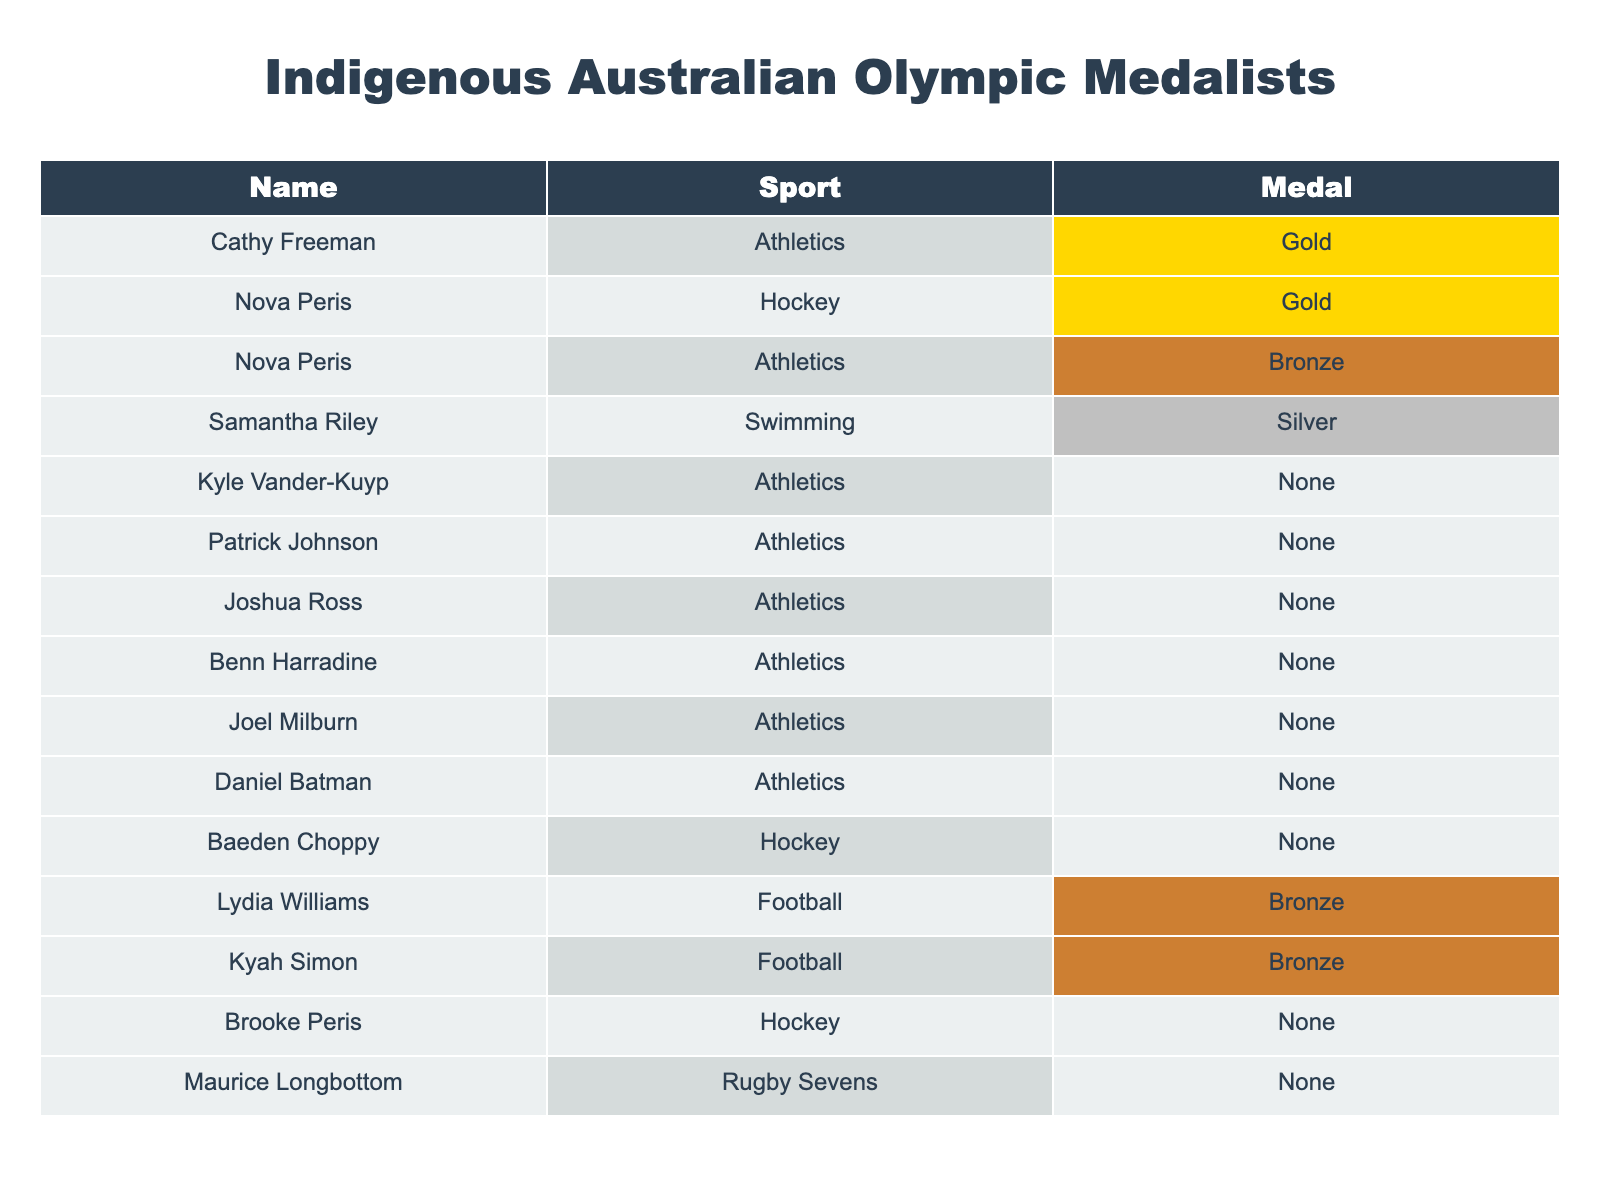What sport did Cathy Freeman compete in? Cathy Freeman's row in the table indicates her sport is Athletics.
Answer: Athletics How many gold medals did Nova Peris win in total? Nova Peris is listed with one gold medal in Hockey and also participated in Athletics where she won a bronze medal. Therefore, her total gold medals are 1.
Answer: 1 Did any Indigenous Australian athlete win a gold medal in Swimming? Looking through the table, the entries show that none of the athletes in the Swimming row have a gold medal. Samantha Riley won silver and bronze but no gold.
Answer: No Which Indigenous athlete earned medals in both Hockey and Athletics? Examining the table, Nova Peris is noted for winning a gold medal in Hockey and also participated in Athletics, where she earned a bronze medal.
Answer: Nova Peris How many athletes won medals in Football? The table lists two athletes, Lydia Williams and Kyah Simon, who each won a bronze medal in Football, indicating that they are the only ones who earned medals in this sport.
Answer: 2 What is the total number of medals won by athletes in Athletics? In the Athletics section, summary of medals shows that while Cathy Freeman has one gold, the others (Kyle Vander-Kuyp, Patrick Johnson, Joshua Ross, Benn Harradine, Joel Milburn, Daniel Batman) did not win medals, thus total medals are 1.
Answer: 1 Is there any athlete in the table who has not won any medals? The table lists Baeden Choppy, Kyle Vander-Kuyp, Patrick Johnson, Joshua Ross, Benn Harradine, Joel Milburn, Daniel Batman, and Maurice Longbottom, all of whom have no medals, confirming that there are multiple athletes without any wins.
Answer: Yes Which athlete has the most medals and how many? The only athlete with a medal count above zero is Cathy Freeman, who has 1 gold medal. All others have fewer, so only Freeman has a peak at this tally.
Answer: 1 medal (Cathy Freeman) 